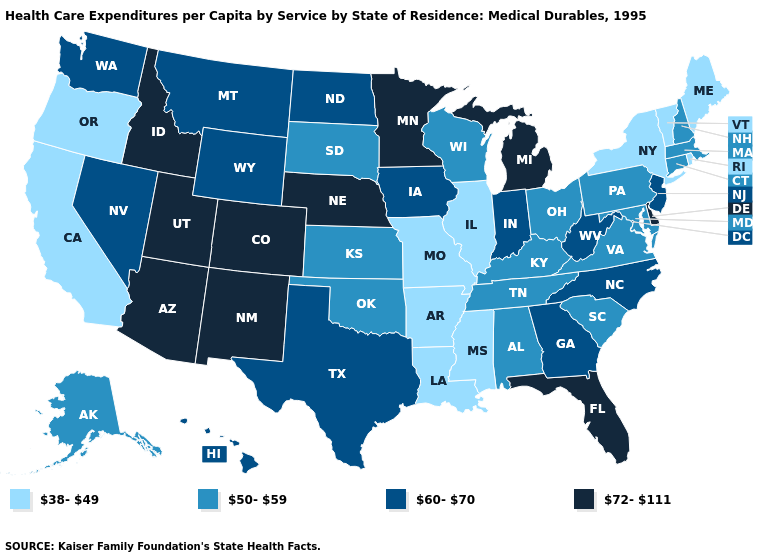Does Minnesota have the highest value in the MidWest?
Short answer required. Yes. Among the states that border Louisiana , does Mississippi have the lowest value?
Concise answer only. Yes. Does North Dakota have the highest value in the MidWest?
Write a very short answer. No. Does Missouri have the lowest value in the MidWest?
Quick response, please. Yes. Does Idaho have the lowest value in the USA?
Keep it brief. No. Among the states that border Delaware , does New Jersey have the highest value?
Answer briefly. Yes. What is the highest value in states that border Colorado?
Short answer required. 72-111. What is the value of Tennessee?
Give a very brief answer. 50-59. Name the states that have a value in the range 50-59?
Be succinct. Alabama, Alaska, Connecticut, Kansas, Kentucky, Maryland, Massachusetts, New Hampshire, Ohio, Oklahoma, Pennsylvania, South Carolina, South Dakota, Tennessee, Virginia, Wisconsin. Among the states that border Virginia , does North Carolina have the highest value?
Quick response, please. Yes. Name the states that have a value in the range 38-49?
Short answer required. Arkansas, California, Illinois, Louisiana, Maine, Mississippi, Missouri, New York, Oregon, Rhode Island, Vermont. What is the value of Alabama?
Quick response, please. 50-59. What is the value of South Dakota?
Be succinct. 50-59. What is the value of Tennessee?
Quick response, please. 50-59. Which states have the lowest value in the West?
Quick response, please. California, Oregon. 